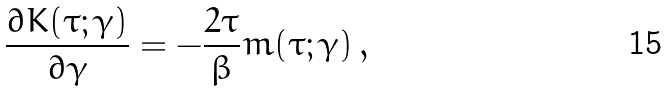<formula> <loc_0><loc_0><loc_500><loc_500>\frac { \partial K ( \tau ; \gamma ) } { \partial \gamma } = - \frac { 2 \tau } { \beta } m ( \tau ; \gamma ) \, ,</formula> 